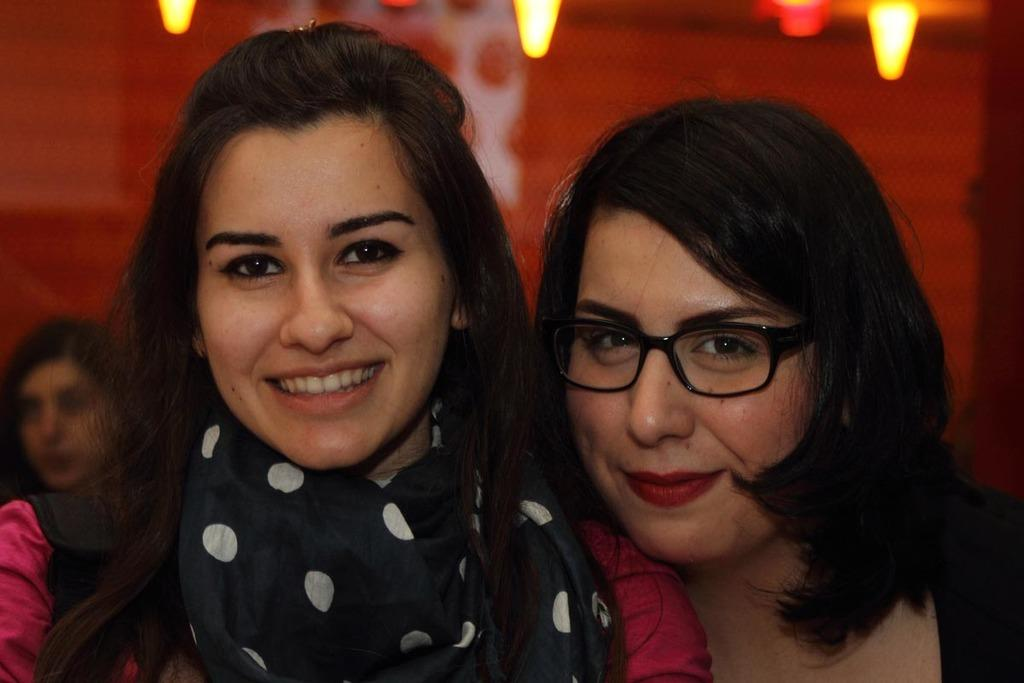How many women are in the image? There are two women standing and smiling in the image. What is the background of the image? There is a wall visible behind the women. What can be seen at the top of the image? There are lights at the top of the image. Where is the third woman in the image? There is a woman sitting at the bottom left side of the image. What type of pig can be seen in the image? There is no pig present in the image. How many rats are visible in the image? There are no rats visible in the image. 